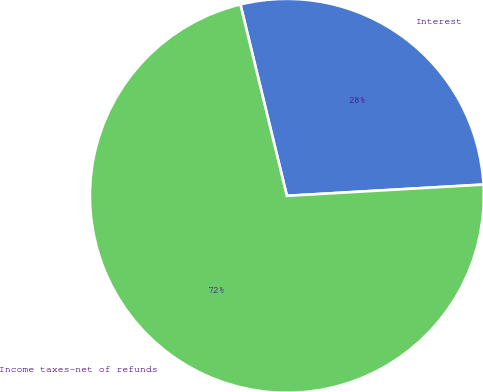Convert chart to OTSL. <chart><loc_0><loc_0><loc_500><loc_500><pie_chart><fcel>Interest<fcel>Income taxes-net of refunds<nl><fcel>27.88%<fcel>72.12%<nl></chart> 